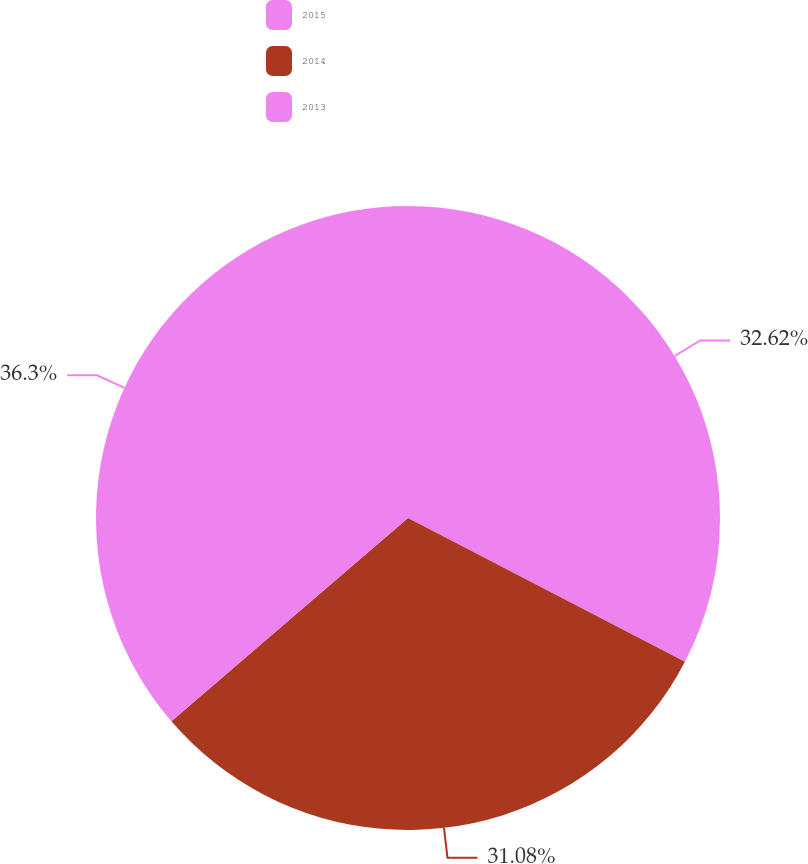<chart> <loc_0><loc_0><loc_500><loc_500><pie_chart><fcel>2015<fcel>2014<fcel>2013<nl><fcel>32.62%<fcel>31.08%<fcel>36.3%<nl></chart> 